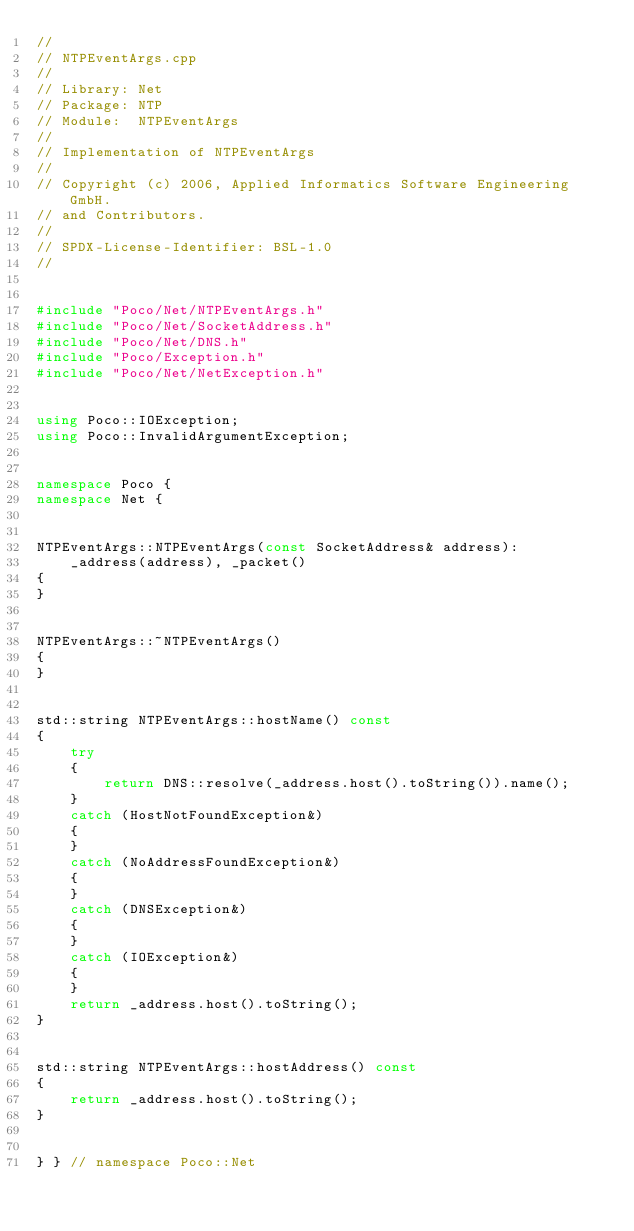<code> <loc_0><loc_0><loc_500><loc_500><_C++_>//
// NTPEventArgs.cpp
//
// Library: Net
// Package: NTP
// Module:  NTPEventArgs
//
// Implementation of NTPEventArgs
//
// Copyright (c) 2006, Applied Informatics Software Engineering GmbH.
// and Contributors.
//
// SPDX-License-Identifier:	BSL-1.0
//


#include "Poco/Net/NTPEventArgs.h"
#include "Poco/Net/SocketAddress.h"
#include "Poco/Net/DNS.h"
#include "Poco/Exception.h"
#include "Poco/Net/NetException.h"


using Poco::IOException;
using Poco::InvalidArgumentException;


namespace Poco {
namespace Net {


NTPEventArgs::NTPEventArgs(const SocketAddress& address):
	_address(address), _packet()
{
}


NTPEventArgs::~NTPEventArgs()
{
}


std::string NTPEventArgs::hostName() const
{
	try
	{
		return DNS::resolve(_address.host().toString()).name();
	}
	catch (HostNotFoundException&) 
	{
	}
	catch (NoAddressFoundException&) 
	{
	}
	catch (DNSException&)
	{
	}
	catch (IOException&)
	{
	}
	return _address.host().toString();
}


std::string NTPEventArgs::hostAddress() const
{
	return _address.host().toString();
}


} } // namespace Poco::Net
</code> 